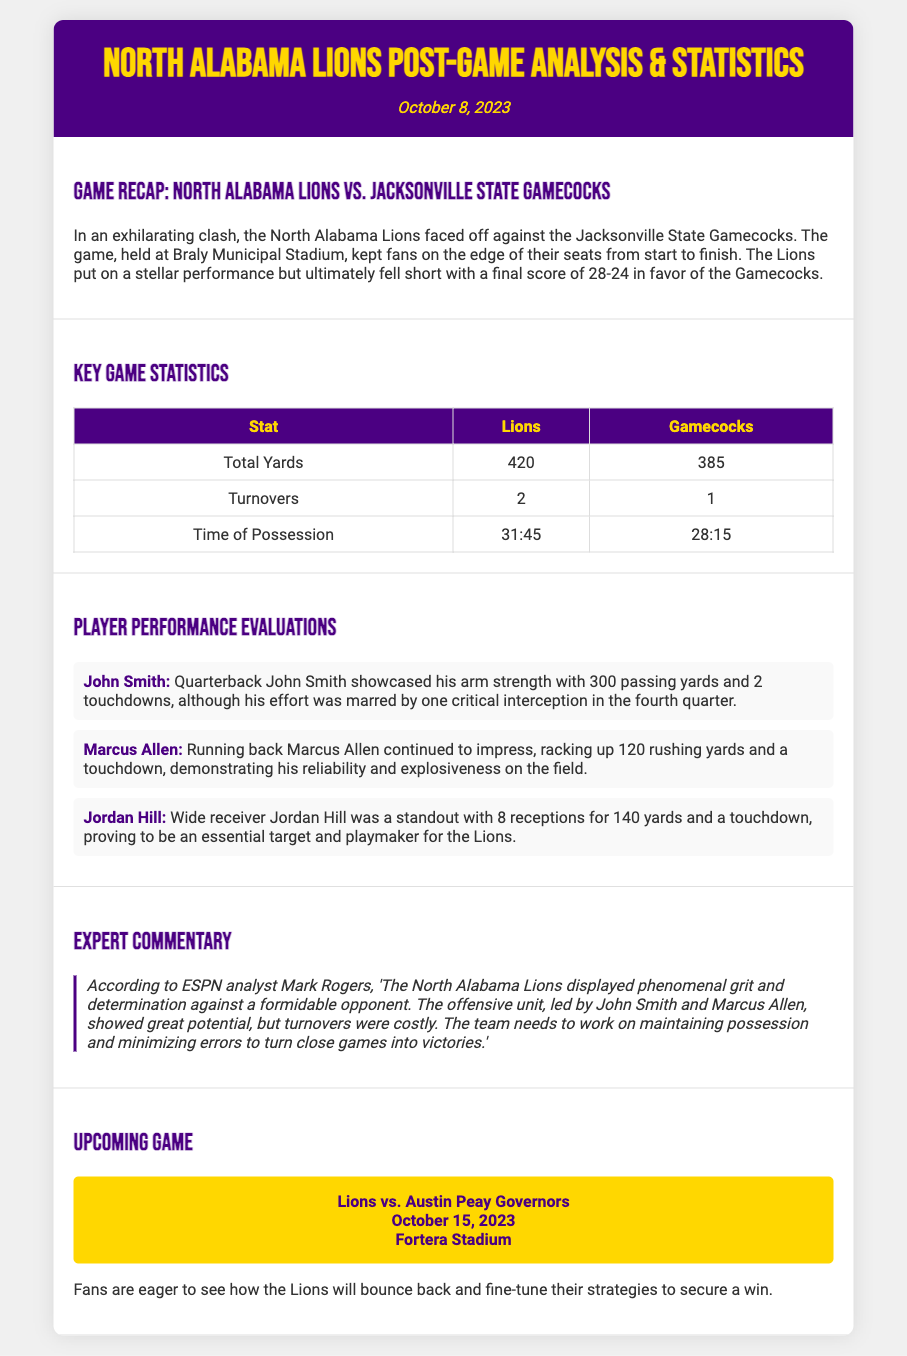What was the final score of the game? The final score is a specific statistic presented in the recap section, indicating the outcome of the game.
Answer: 28-24 Who did the North Alabama Lions play against? The opponent team is mentioned explicitly in the game recap section of the document.
Answer: Jacksonville State Gamecocks How many total yards did the Lions achieve? The total yards statistic is provided in the key game statistics table, showing the offensive performance of the Lions.
Answer: 420 What was John Smith's passing yards? This information is derived from the player performance evaluations, detailing individual statistics for key players.
Answer: 300 According to the expert commentary, what does Mark Rogers suggest the team needs to work on? This reasoning requires understanding expert feedback about team performance and areas for improvement mentioned in the commentary section.
Answer: Minimizing errors How many touchdowns did Marcus Allen score? The player's performance summary contains specific scoring information about Marcus Allen during the game.
Answer: 1 When is the upcoming game scheduled? The date for the next game is listed in the upcoming game section, indicating future events for the team.
Answer: October 15, 2023 What is the name of the upcoming opponent? The upcoming opponent's name is clearly indicated in the upcoming game section, outlining who the Lions will play next.
Answer: Austin Peay Governors 